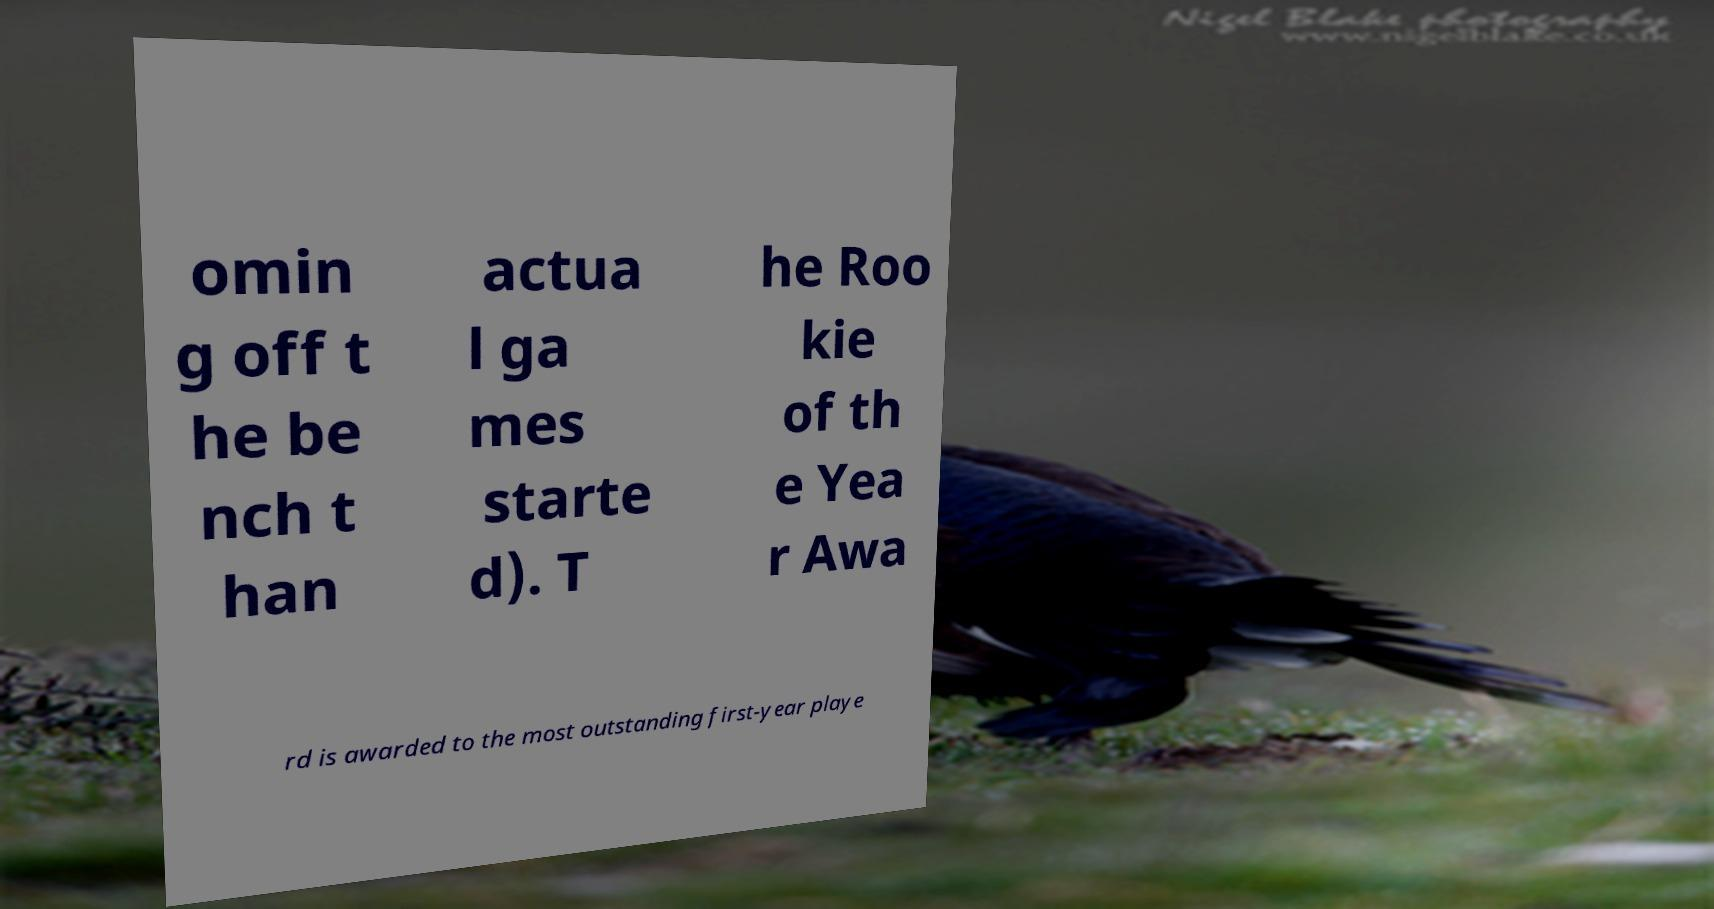Please read and relay the text visible in this image. What does it say? omin g off t he be nch t han actua l ga mes starte d). T he Roo kie of th e Yea r Awa rd is awarded to the most outstanding first-year playe 